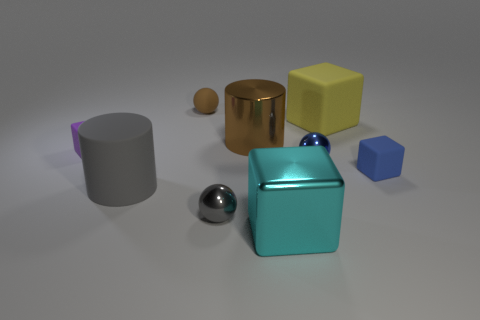Subtract all shiny balls. How many balls are left? 1 Subtract all balls. How many objects are left? 6 Subtract 2 cylinders. How many cylinders are left? 0 Subtract 0 brown blocks. How many objects are left? 9 Subtract all purple blocks. Subtract all yellow balls. How many blocks are left? 3 Subtract all purple objects. Subtract all purple matte things. How many objects are left? 7 Add 5 small blue things. How many small blue things are left? 7 Add 5 large gray matte cylinders. How many large gray matte cylinders exist? 6 Subtract all gray cylinders. How many cylinders are left? 1 